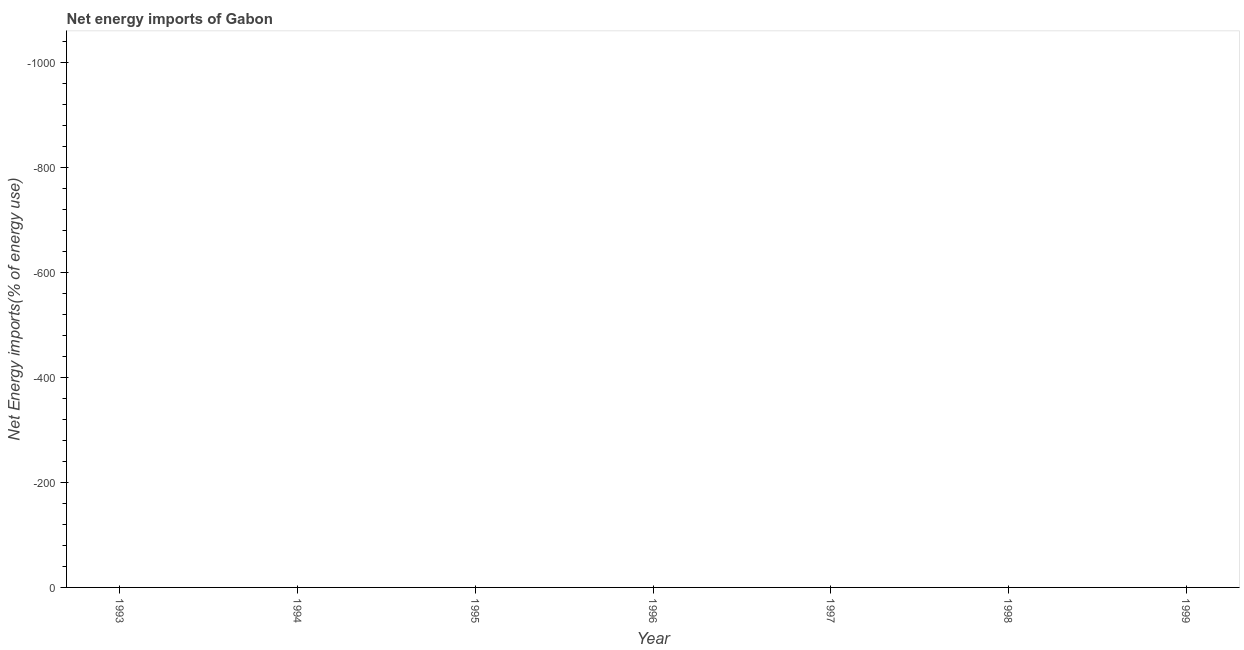What is the energy imports in 1998?
Your answer should be very brief. 0. What is the average energy imports per year?
Make the answer very short. 0. What is the median energy imports?
Provide a short and direct response. 0. In how many years, is the energy imports greater than -40 %?
Your response must be concise. 0. What is the difference between two consecutive major ticks on the Y-axis?
Provide a short and direct response. 200. Are the values on the major ticks of Y-axis written in scientific E-notation?
Keep it short and to the point. No. What is the title of the graph?
Make the answer very short. Net energy imports of Gabon. What is the label or title of the Y-axis?
Offer a very short reply. Net Energy imports(% of energy use). What is the Net Energy imports(% of energy use) in 1994?
Offer a terse response. 0. What is the Net Energy imports(% of energy use) in 1995?
Provide a short and direct response. 0. What is the Net Energy imports(% of energy use) in 1997?
Your answer should be very brief. 0. What is the Net Energy imports(% of energy use) in 1998?
Offer a very short reply. 0. 